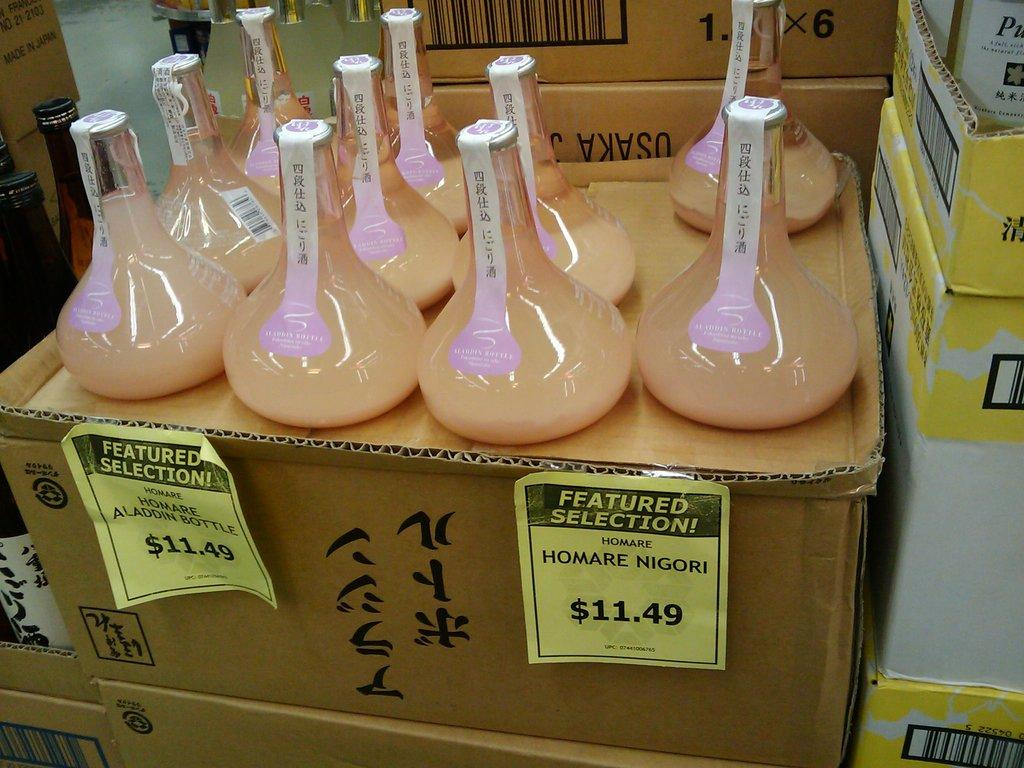<image>
Give a short and clear explanation of the subsequent image. Bottles of Homare are displayed and they are $11.49 each. 